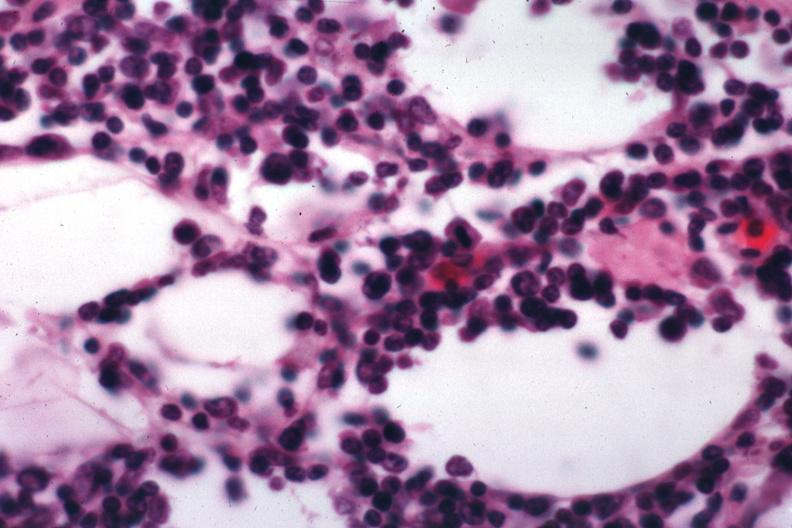does eosinophilic adenoma show lymphocytic infiltration in perinodal fat?
Answer the question using a single word or phrase. No 